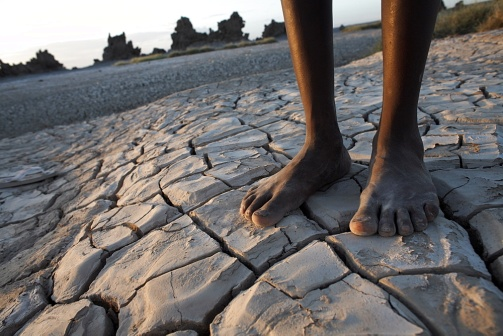What time of day does this photo seem to capture? The warm, orange glow on the horizon and lengthening shadows suggest that this photo captures the evening, likely around sunset. The absence of harsh shadows indicates the sun is low in the sky. 